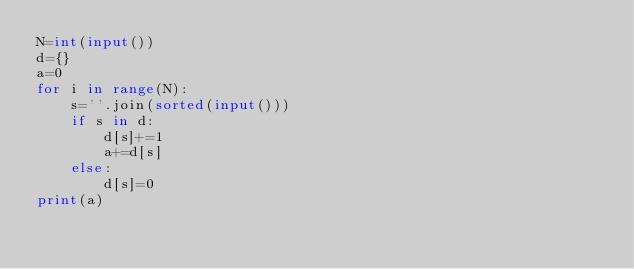<code> <loc_0><loc_0><loc_500><loc_500><_Python_>N=int(input())
d={}
a=0
for i in range(N):
    s=''.join(sorted(input()))
    if s in d:
        d[s]+=1
        a+=d[s]
    else:
        d[s]=0
print(a)</code> 